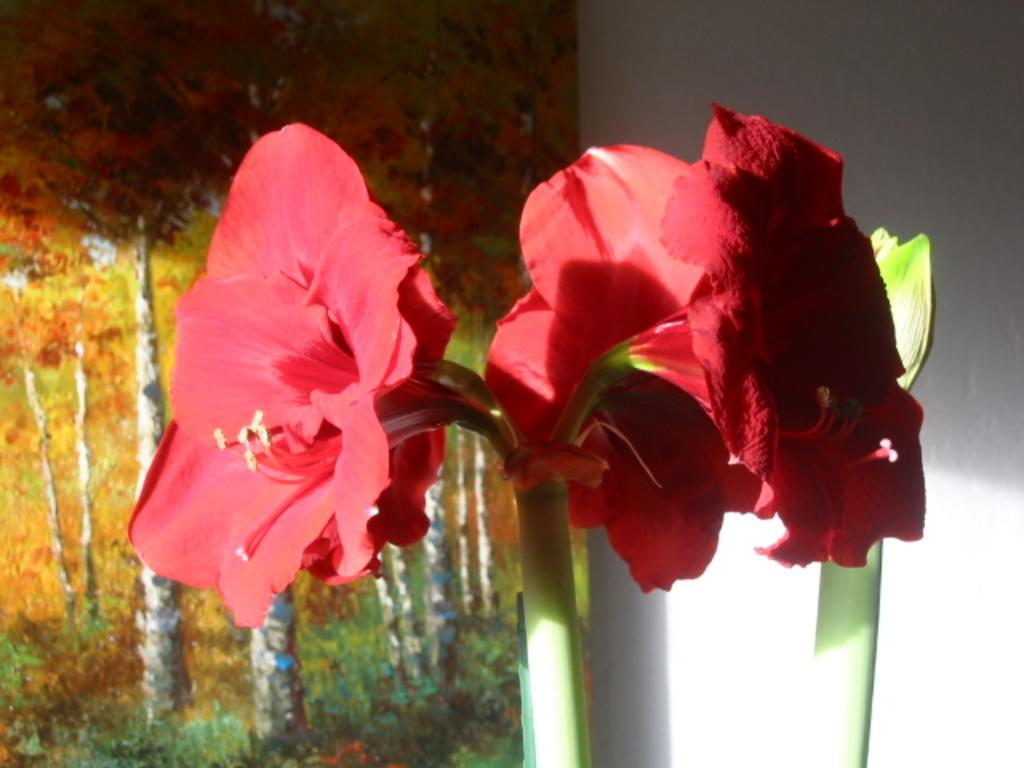What type of flowers can be seen in the image? There are red color flowers in the image. What else is present in the image besides the flowers? There is a colorful board visible in the image. What is the color of the wall in the background of the image? There is a white wall in the background of the image. What type of leather is being shown in the image? There is no leather present in the image. Can you describe the running shoes in the image? There are no running shoes present in the image. 